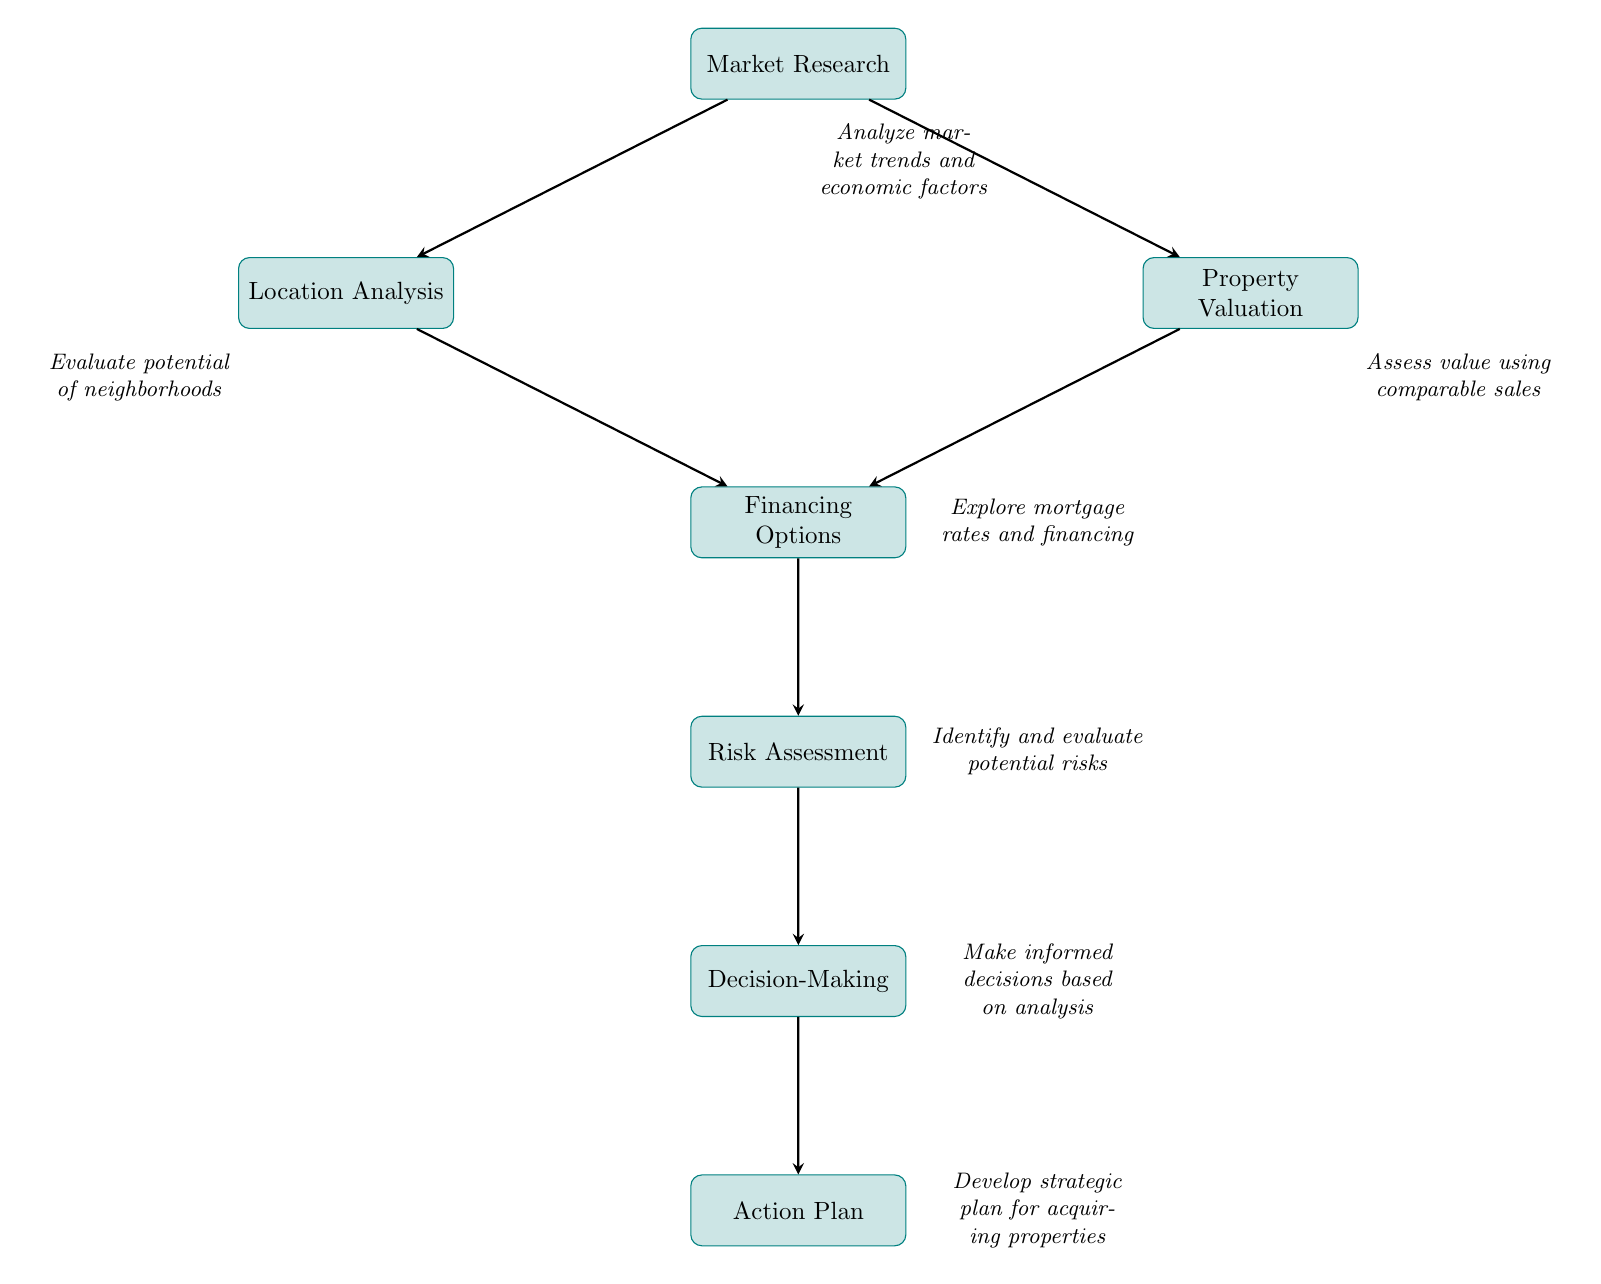What is the first step in the diagram? The first step is represented by the node labeled “Market Research.” It is the starting point and does not have any previous nodes leading to it.
Answer: Market Research How many nodes are present in the diagram? The diagram contains a total of seven nodes, each representing a distinct step in the real estate analysis process.
Answer: Seven What does the node "Financing Options" lead to? The node "Financing Options" leads to the next step, which is "Risk Assessment." This shows the sequential flow in the analysis process.
Answer: Risk Assessment Which two nodes lead to "Financing Options"? The nodes that lead to "Financing Options" are "Location Analysis" and "Property Valuation," both contributing to the financing consideration.
Answer: Location Analysis and Property Valuation What is the relationship between "Market Research" and "Decision-Making"? "Market Research" ultimately contributes to the "Decision-Making" step as it is the first step in the flow, influencing further analysis and evaluations.
Answer: Indirect relationship through successive steps Which step immediately follows "Risk Assessment"? The step that immediately follows "Risk Assessment" is "Decision-Making," indicating the progression toward making informed choices based on previous analyses.
Answer: Decision-Making What type of analysis is performed right before making decisions? The analysis performed right before "Decision-Making" is "Risk Assessment." This step involves identifying and evaluating potential risks before deciding.
Answer: Risk Assessment What is the final outcome of the flow chart? The final outcome represented in the diagram is "Action Plan," which indicates the strategic planning for acquiring properties after thorough analysis.
Answer: Action Plan 